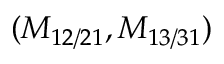<formula> <loc_0><loc_0><loc_500><loc_500>( M _ { 1 2 / 2 1 } , M _ { 1 3 / 3 1 } )</formula> 